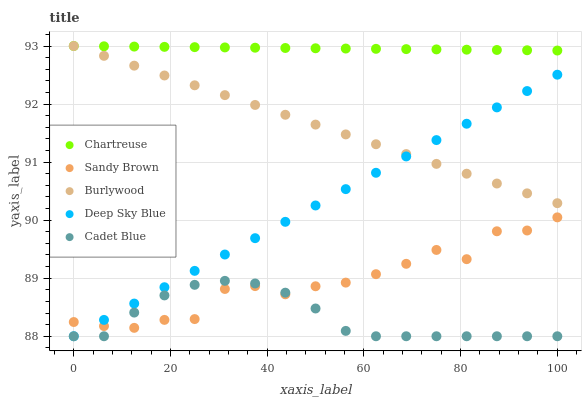Does Cadet Blue have the minimum area under the curve?
Answer yes or no. Yes. Does Chartreuse have the maximum area under the curve?
Answer yes or no. Yes. Does Chartreuse have the minimum area under the curve?
Answer yes or no. No. Does Cadet Blue have the maximum area under the curve?
Answer yes or no. No. Is Deep Sky Blue the smoothest?
Answer yes or no. Yes. Is Sandy Brown the roughest?
Answer yes or no. Yes. Is Chartreuse the smoothest?
Answer yes or no. No. Is Chartreuse the roughest?
Answer yes or no. No. Does Cadet Blue have the lowest value?
Answer yes or no. Yes. Does Chartreuse have the lowest value?
Answer yes or no. No. Does Chartreuse have the highest value?
Answer yes or no. Yes. Does Cadet Blue have the highest value?
Answer yes or no. No. Is Cadet Blue less than Burlywood?
Answer yes or no. Yes. Is Chartreuse greater than Cadet Blue?
Answer yes or no. Yes. Does Burlywood intersect Deep Sky Blue?
Answer yes or no. Yes. Is Burlywood less than Deep Sky Blue?
Answer yes or no. No. Is Burlywood greater than Deep Sky Blue?
Answer yes or no. No. Does Cadet Blue intersect Burlywood?
Answer yes or no. No. 